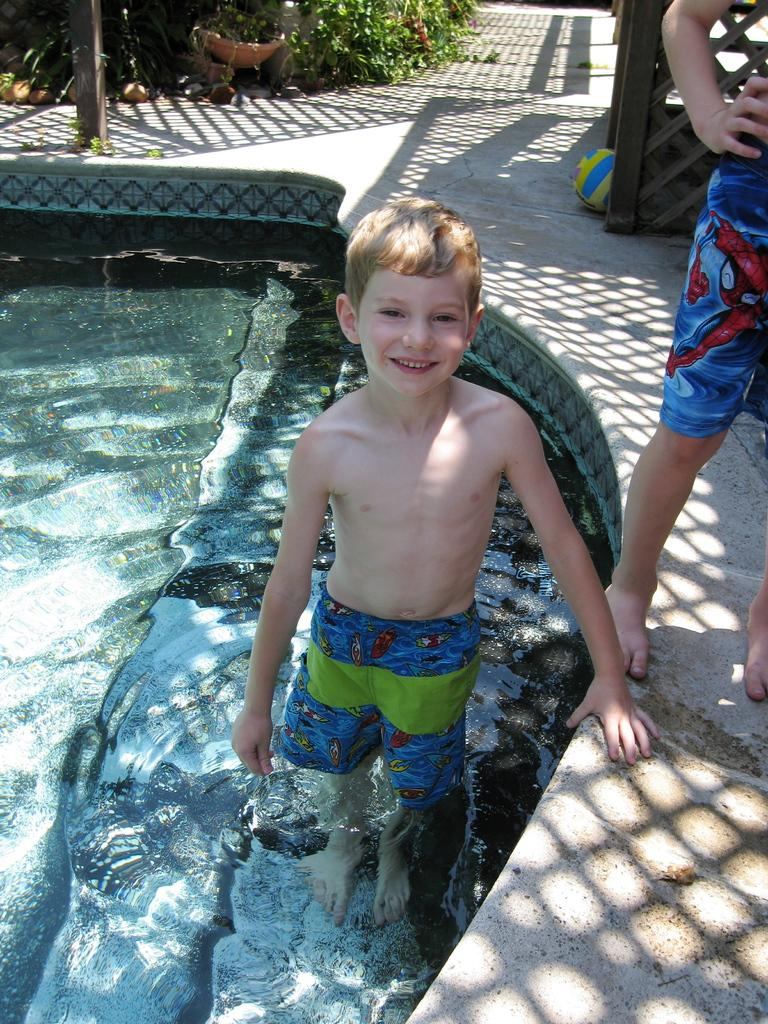What is the main subject of the image? There is a child in the image. What is the child wearing? The child is wearing shorts. What can be seen in the background of the image? There is water visible in the image. What object is present in the image that is commonly used for playing? There is a ball in the image. What structure can be seen in the image? There is a pole in the image. What type of surface is visible in the image? There is grass in the image. Who else is present in the image besides the child? There is another person standing beside the child, wearing shorts. What can be observed about the other person's shadow in the image? The other person's shadow is visible in the image. What type of kettle is visible in the image? There is no kettle present in the image. What type of cable can be seen connecting the ball to the pole in the image? There is no cable connecting the ball to the pole in the image; the ball is simply lying on the grass. What type of baseball game is being played in the image? There is no baseball game present in the image; it is a scene with a child, another person, a ball, and a pole. 